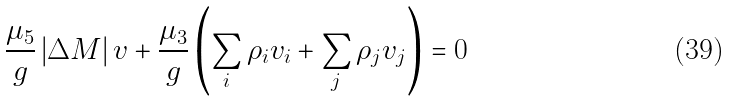<formula> <loc_0><loc_0><loc_500><loc_500>\frac { \mu _ { 5 } } { g } \left | \Delta M \right | v + \frac { \mu _ { 3 } } { g } \left ( \sum _ { i } \rho _ { i } v _ { i } + \sum _ { j } \rho _ { j } v _ { j } \right ) = 0</formula> 